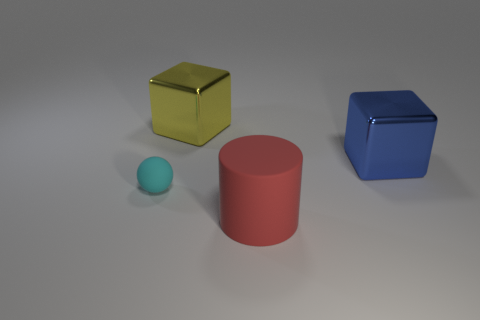Subtract all red cubes. Subtract all yellow balls. How many cubes are left? 2 Add 1 red metal things. How many objects exist? 5 Subtract all cylinders. How many objects are left? 3 Subtract 0 brown cylinders. How many objects are left? 4 Subtract all big yellow metal things. Subtract all large yellow things. How many objects are left? 2 Add 1 spheres. How many spheres are left? 2 Add 1 tiny red shiny objects. How many tiny red shiny objects exist? 1 